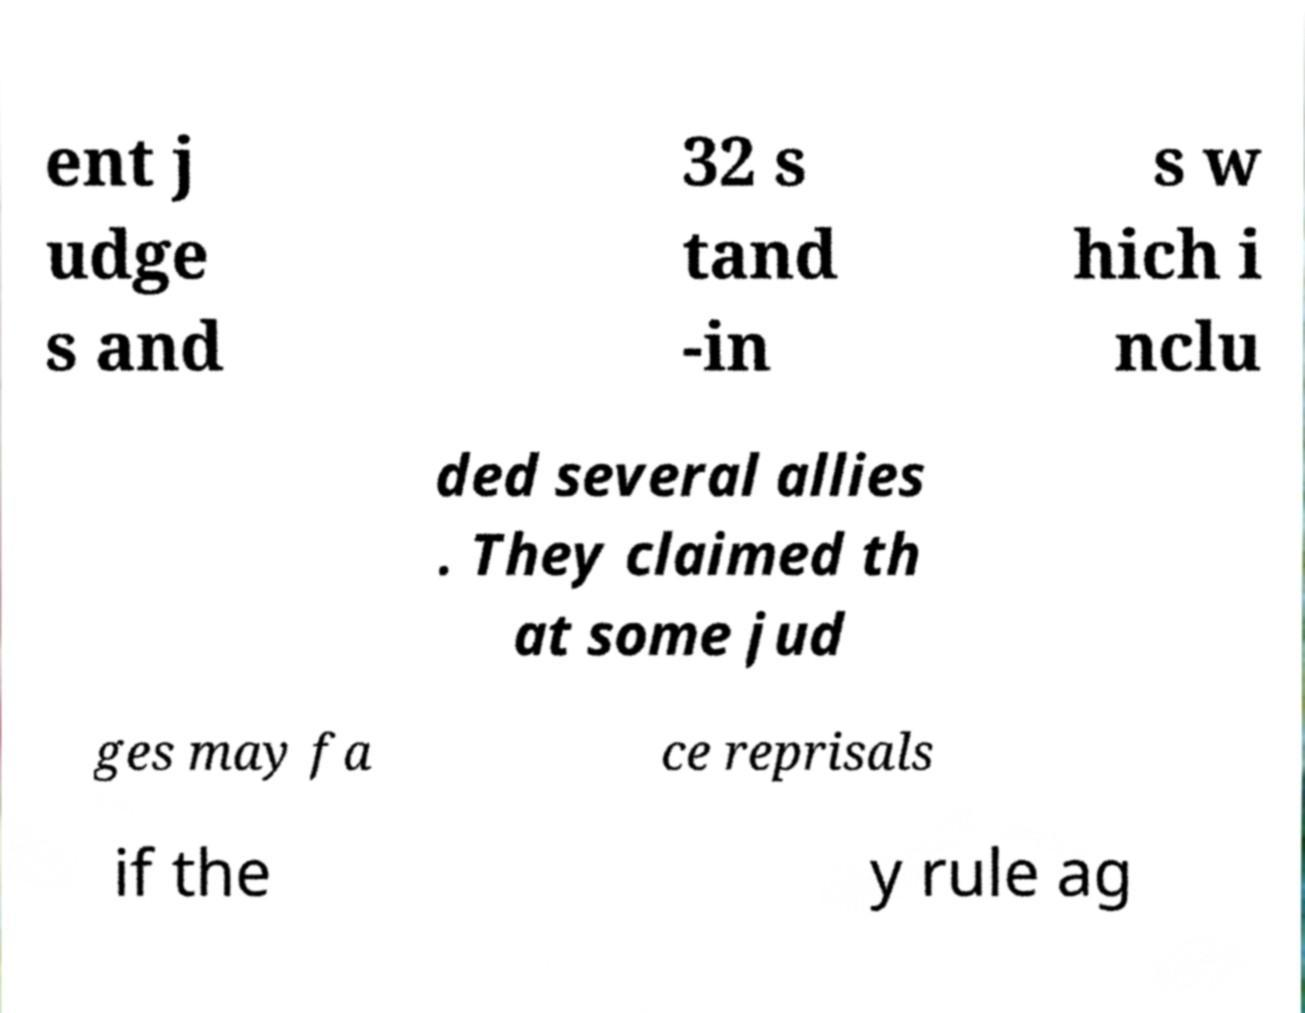What messages or text are displayed in this image? I need them in a readable, typed format. ent j udge s and 32 s tand -in s w hich i nclu ded several allies . They claimed th at some jud ges may fa ce reprisals if the y rule ag 